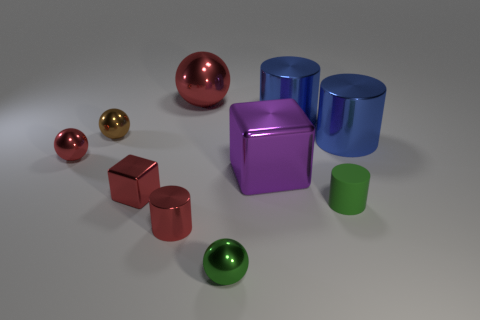Could you describe the textures seen on the surfaces in the image? Certainly! The textures on the objects in the image range from smooth and reflective to slightly matte. The metallic objects, particularly, exhibit a mirror-like finish that clearly reflects the environment, while other surfaces have a more subdued sheen, indicating a satin-like texture that softly diffuses light. Which colors are predominant in the image, and how do they contribute to the overall mood? The image features a range of cool tones, including blues, purples, and greens, juxtaposed with warmer hues like red and copper. These colors contribute to a harmonious and balanced visual experience, evoking a sense of calmness and order. The cool colors typically convey a sense of sophistication and modernity, while the warmer tones add a touch of energy and contrast. 